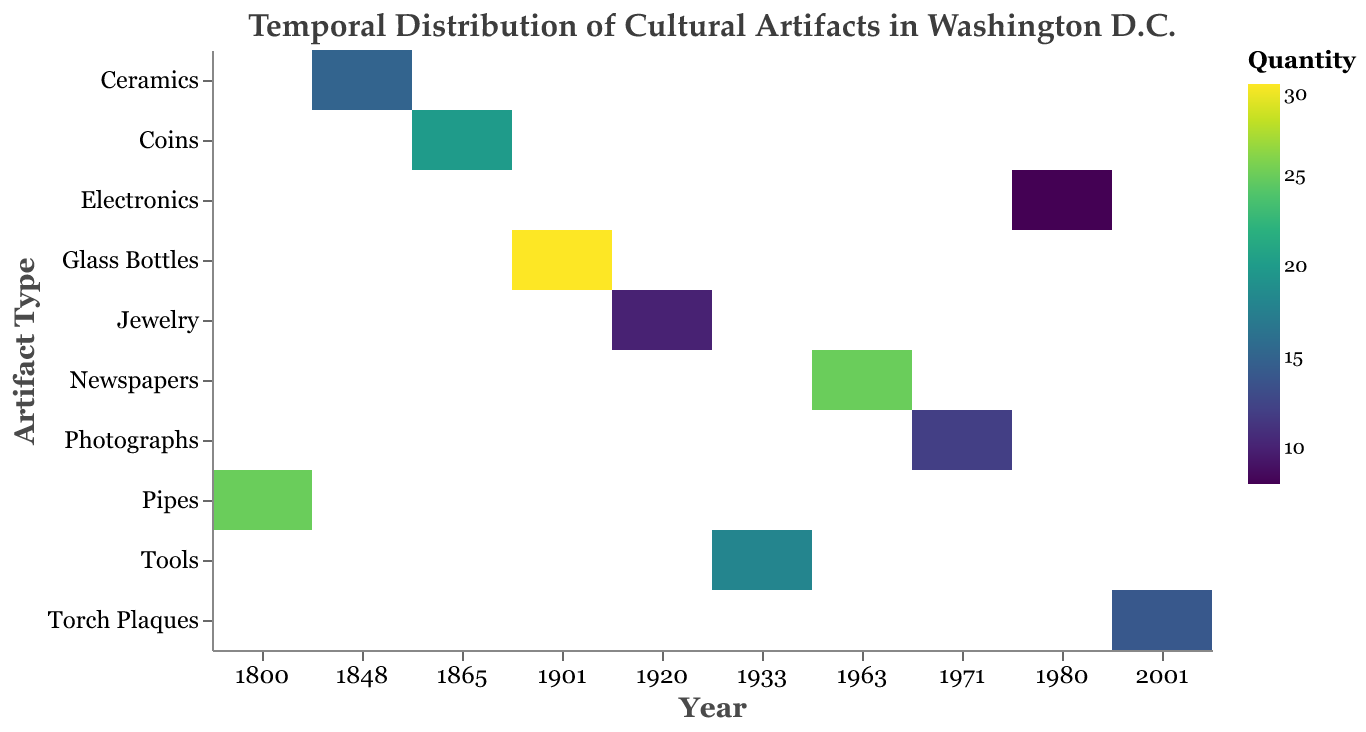What's the title of the figure? The title is provided at the top of the figure and it states, "Temporal Distribution of Cultural Artifacts in Washington D.C."
Answer: Temporal Distribution of Cultural Artifacts in Washington D.C Which artifact type was unearthed the most in 1901? To find the artifact type unearthed the most in 1901, look at the color intensity for the year 1901 on the heatmap. The darkest color represents the highest quantity, which is Glass Bottles with a quantity of 30.
Answer: Glass Bottles In which year were Newspapers unearthed, and during what historical event? Find the row for Newspapers in the heatmap and check the corresponding year column and tooltip for the historical event. Newspapers are listed under 1963, corresponding to the "March on Washington for Jobs and Freedom."
Answer: 1963, March on Washington for Jobs and Freedom What is the quantity difference between Pipes unearthed in 1800 and Coins unearthed in 1865? Identify the quantities for Pipes in 1800 (25) and Coins in 1865 (20). Subtract the quantity of Coins from the quantity of Pipes: 25 - 20 = 5.
Answer: 5 How does the quantity of Tools unearthed in 1933 compare to the quantity of Torch Plaques unearthed in 2001? Find the quantities for Tools in 1933 (18) and Torch Plaques in 2001 (14). Compare the numbers: 18 is greater than 14.
Answer: Tools unearthed in 1933 are more than Torch Plaques in 2001 Which artifacts were unearthed during significant events related to presidential history? Look for historical events in the tooltip that mention presidents: "Assassination of President McKinley" in 1901 (Glass Bottles) and "Ronald Reagan's Election" in 1980 (Electronics). The artifacts are Glass Bottles and Electronics.
Answer: Glass Bottles, Electronics During which historical event were the most artifacts unearthed? Identify the darkest color on the heatmap to find the maximum quantity, which is Glass Bottles (30) in 1901 during the "Assassination of President McKinley."
Answer: Assassination of President McKinley What is the average quantity of artifacts unearthed during the "Women's Suffrage" in 1920 and the "New Deal Programs" in 1933? Find the quantities for Jewelry in 1920 (10) and Tools in 1933 (18). Calculate the average: (10 + 18) / 2 = 14.
Answer: 14 